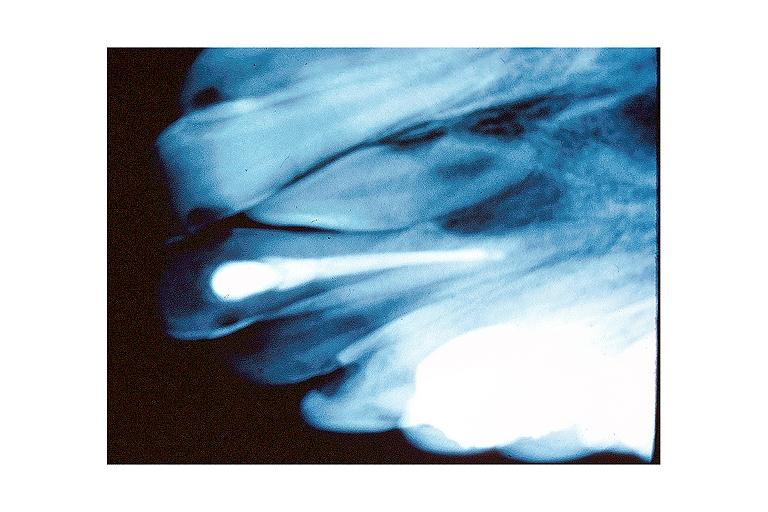does infiltrative process show mesiodens?
Answer the question using a single word or phrase. No 